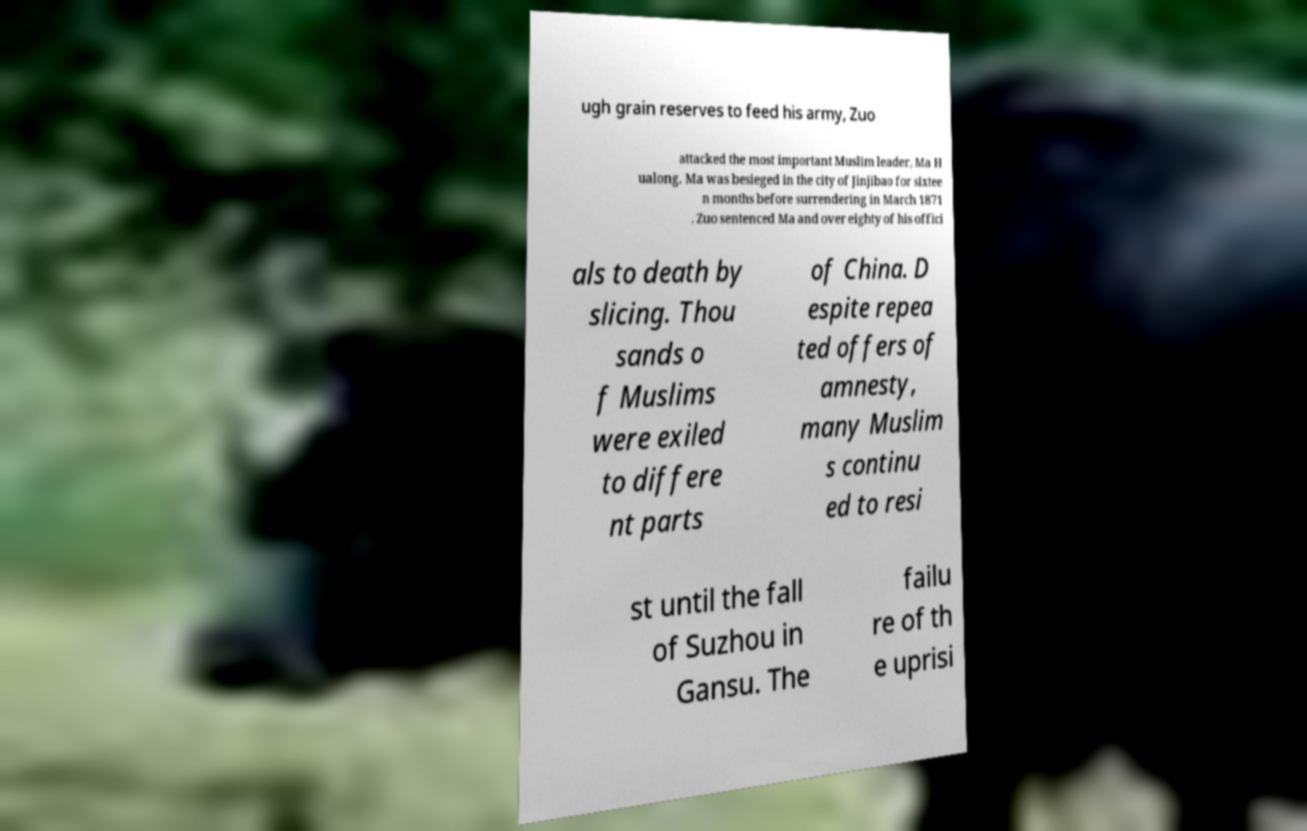Could you assist in decoding the text presented in this image and type it out clearly? ugh grain reserves to feed his army, Zuo attacked the most important Muslim leader, Ma H ualong. Ma was besieged in the city of Jinjibao for sixtee n months before surrendering in March 1871 . Zuo sentenced Ma and over eighty of his offici als to death by slicing. Thou sands o f Muslims were exiled to differe nt parts of China. D espite repea ted offers of amnesty, many Muslim s continu ed to resi st until the fall of Suzhou in Gansu. The failu re of th e uprisi 